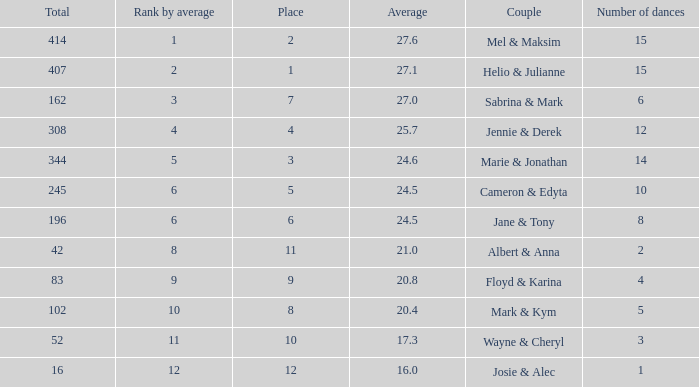What is the smallest place number when the total is 16 and average is less than 16? None. I'm looking to parse the entire table for insights. Could you assist me with that? {'header': ['Total', 'Rank by average', 'Place', 'Average', 'Couple', 'Number of dances'], 'rows': [['414', '1', '2', '27.6', 'Mel & Maksim', '15'], ['407', '2', '1', '27.1', 'Helio & Julianne', '15'], ['162', '3', '7', '27.0', 'Sabrina & Mark', '6'], ['308', '4', '4', '25.7', 'Jennie & Derek', '12'], ['344', '5', '3', '24.6', 'Marie & Jonathan', '14'], ['245', '6', '5', '24.5', 'Cameron & Edyta', '10'], ['196', '6', '6', '24.5', 'Jane & Tony', '8'], ['42', '8', '11', '21.0', 'Albert & Anna', '2'], ['83', '9', '9', '20.8', 'Floyd & Karina', '4'], ['102', '10', '8', '20.4', 'Mark & Kym', '5'], ['52', '11', '10', '17.3', 'Wayne & Cheryl', '3'], ['16', '12', '12', '16.0', 'Josie & Alec', '1']]} 